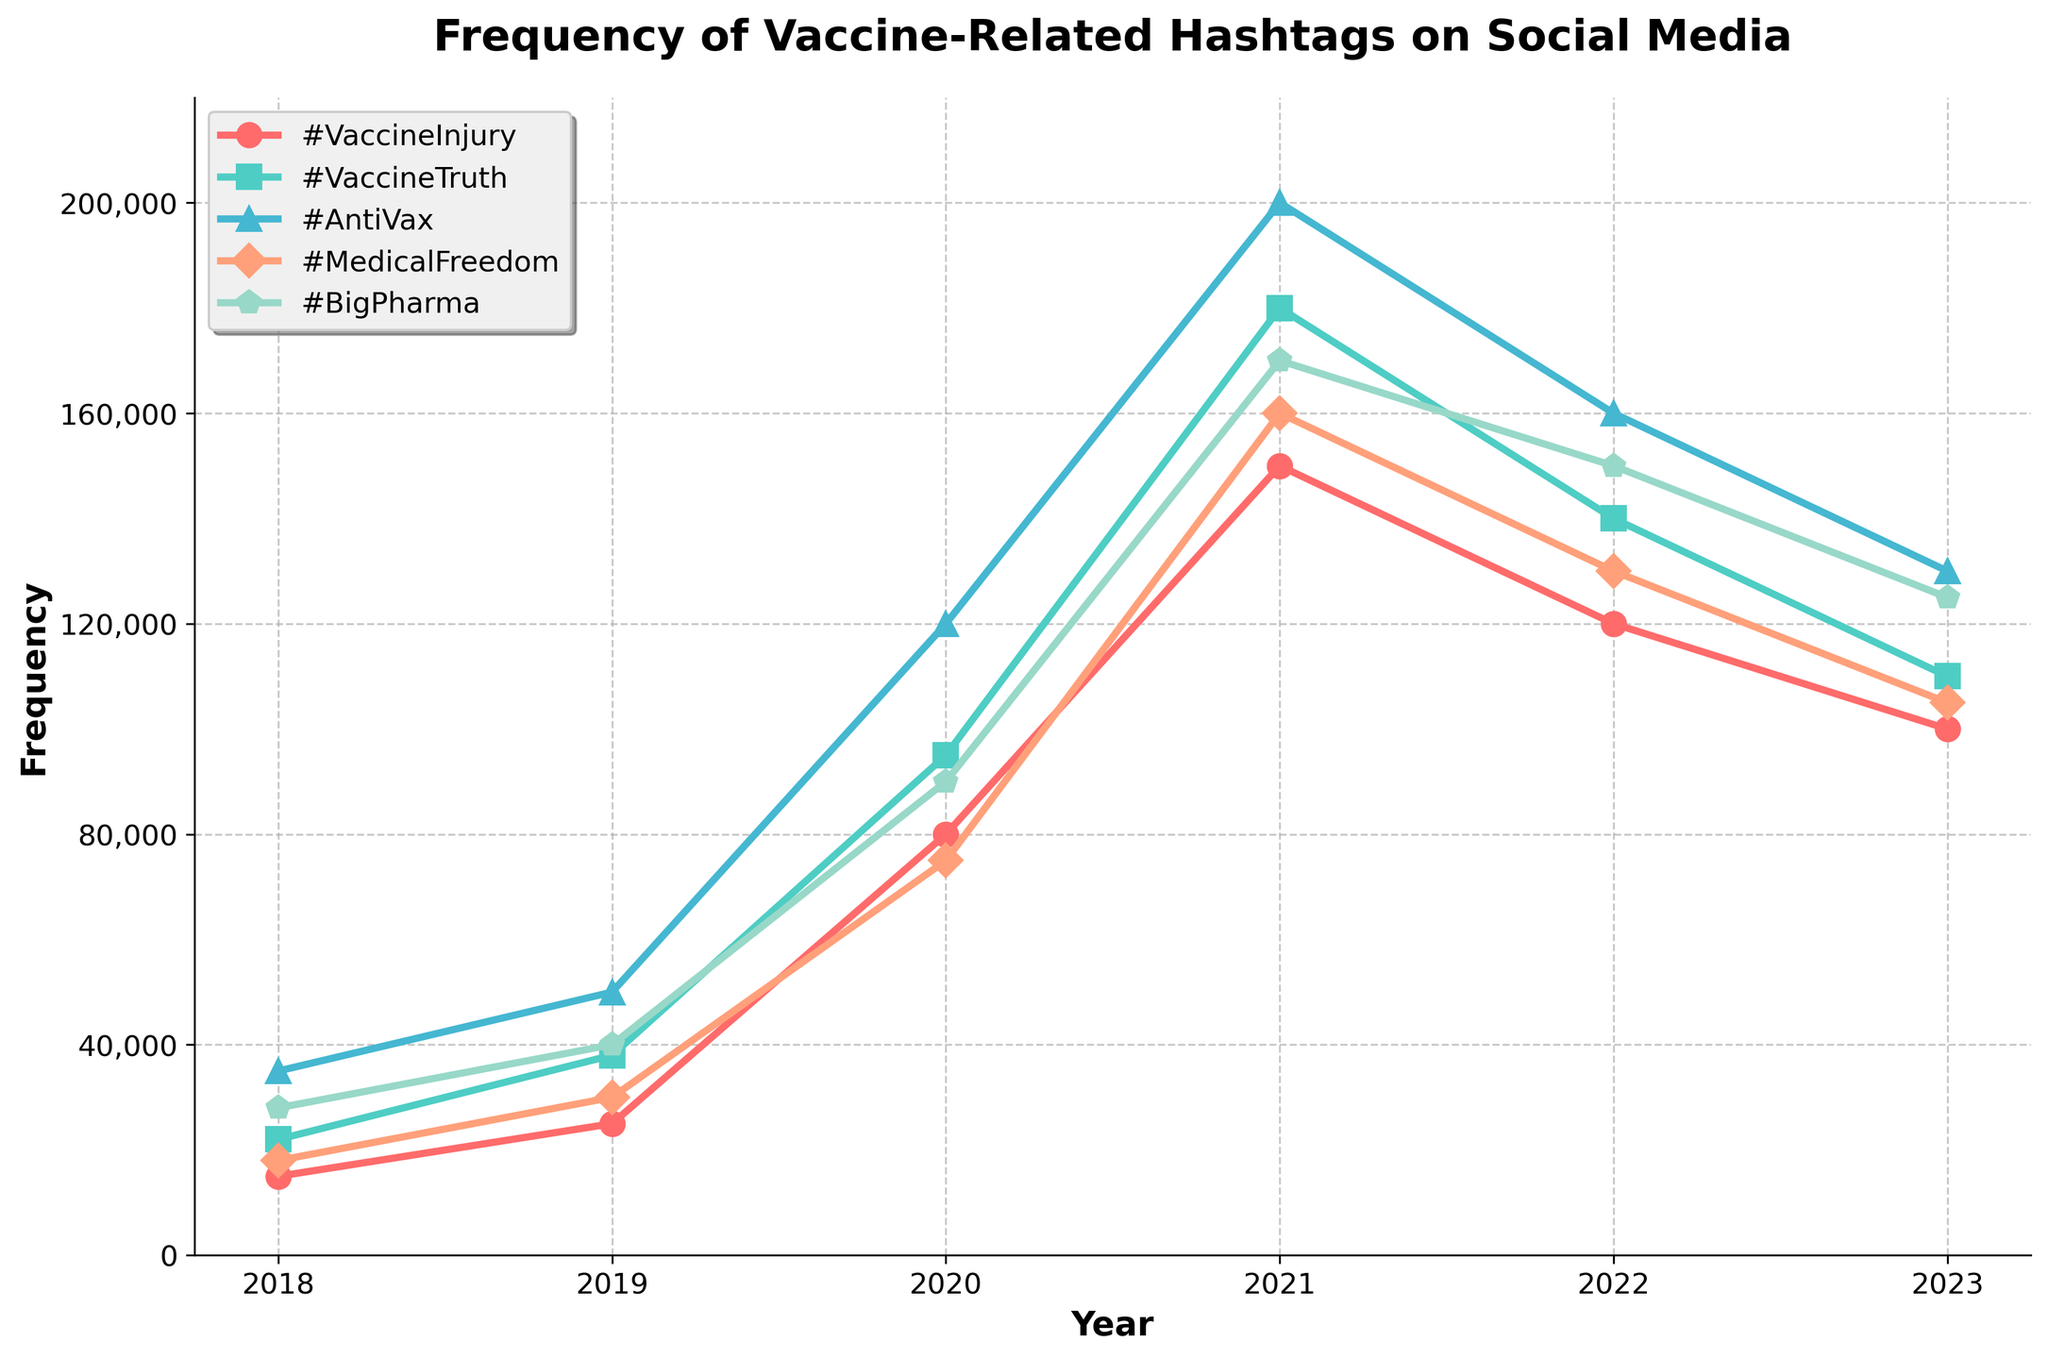What is the highest frequency recorded for any hashtag? The highest frequency can be determined by looking at the peaks of all the lines in the chart. The highest point is for #AntiVax in the year 2021, which is at 200,000.
Answer: 200,000 Which hashtag had the most significant increase from 2018 to 2021? To find the most significant increase, look at the difference in frequencies between 2018 and 2021 for each hashtag. #AntiVax went from 35,000 in 2018 to 200,000 in 2021, an increase of 165,000, which is the most significant.
Answer: #AntiVax What was the trend for the hashtag #VaccineInjury over the past five years? Examine the line representing #VaccineInjury. It increased from 15,000 in 2018 to a peak of 150,000 in 2021, then decreased to 100,000 in 2023. First increasing dramatically and slightly decreasing afterwards.
Answer: It increased, peaked, then decreased How many hashtags exceeded 100,000 in frequency in the year 2020? Look at the frequencies for all hashtags in 2020. #VaccineInjury (80,000), #VaccineTruth (95,000), #AntiVax (120,000), #MedicalFreedom (75,000), and #BigPharma (90,000). Only #AntiVax exceeded 100,000.
Answer: 1 Which two hashtags had the closest frequencies in 2022? To find the closest frequencies in 2022, compare the differences between the frequencies of all hashtags in 2022. #VaccineInjury (120,000) and #BigPharma (150,000) are the closest, with a difference of 30,000.
Answer: #VaccineInjury and #BigPharma What was the percentage increase for the hashtag #MedicalFreedom from 2018 to 2021? Calculate the percentage increase using the formula [(New Value - Old Value)/Old Value]*100. For #MedicalFreedom, it increased from 18,000 in 2018 to 160,000 in 2021. [(160,000 - 18,000)/18,000]*100 = 788.89%.
Answer: 788.89% Which year saw the highest combined frequency of all hashtags? Sum the frequencies of all hashtags for each year: 2018 (118,000), 2019 (183,000), 2020 (470,000), 2021 (860,000), 2022 (700,000), 2023 (570,000). 2021 has the highest combined frequency at 860,000.
Answer: 2021 Between which consecutive years did #AntiVax see its largest increase? Calculate the year-on-year increase for #AntiVax and find the maximum. The increase from 2019 to 2020 was 120,000 - 50,000 = 70,000, which is the largest increase.
Answer: 2019 to 2020 What colors represent #VaccineTruth and #BigPharma in the chart? Identify the colors used for each line. #VaccineTruth is in green (turquoise) and #BigPharma is in light green.
Answer: Green and light green Which hashtag shows the steepest decline from its peak value to 2023? Identify the peak value and the value in 2023 for each hashtag, then calculate the difference. #AntiVax drops from 200,000 in 2021 to 130,000 in 2023, which is a decline of 70,000, the steepest decline.
Answer: #AntiVax 